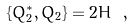Convert formula to latex. <formula><loc_0><loc_0><loc_500><loc_500>\{ Q _ { 2 } ^ { * } , Q _ { 2 } \} = 2 H \ ,</formula> 